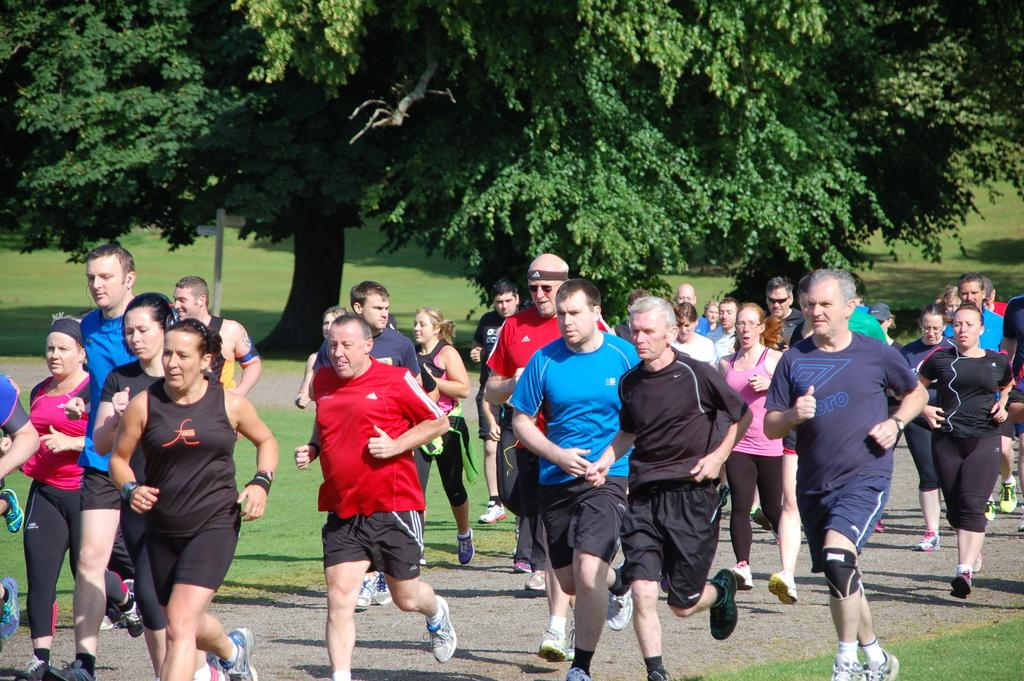What are the people in the image doing? The people in the image are running on the road. What can be seen near the road in the image? There are trees and grass visible near the road. What decision did the trees make in the image? There are no decisions made by trees in the image, as trees do not have the ability to make decisions. 